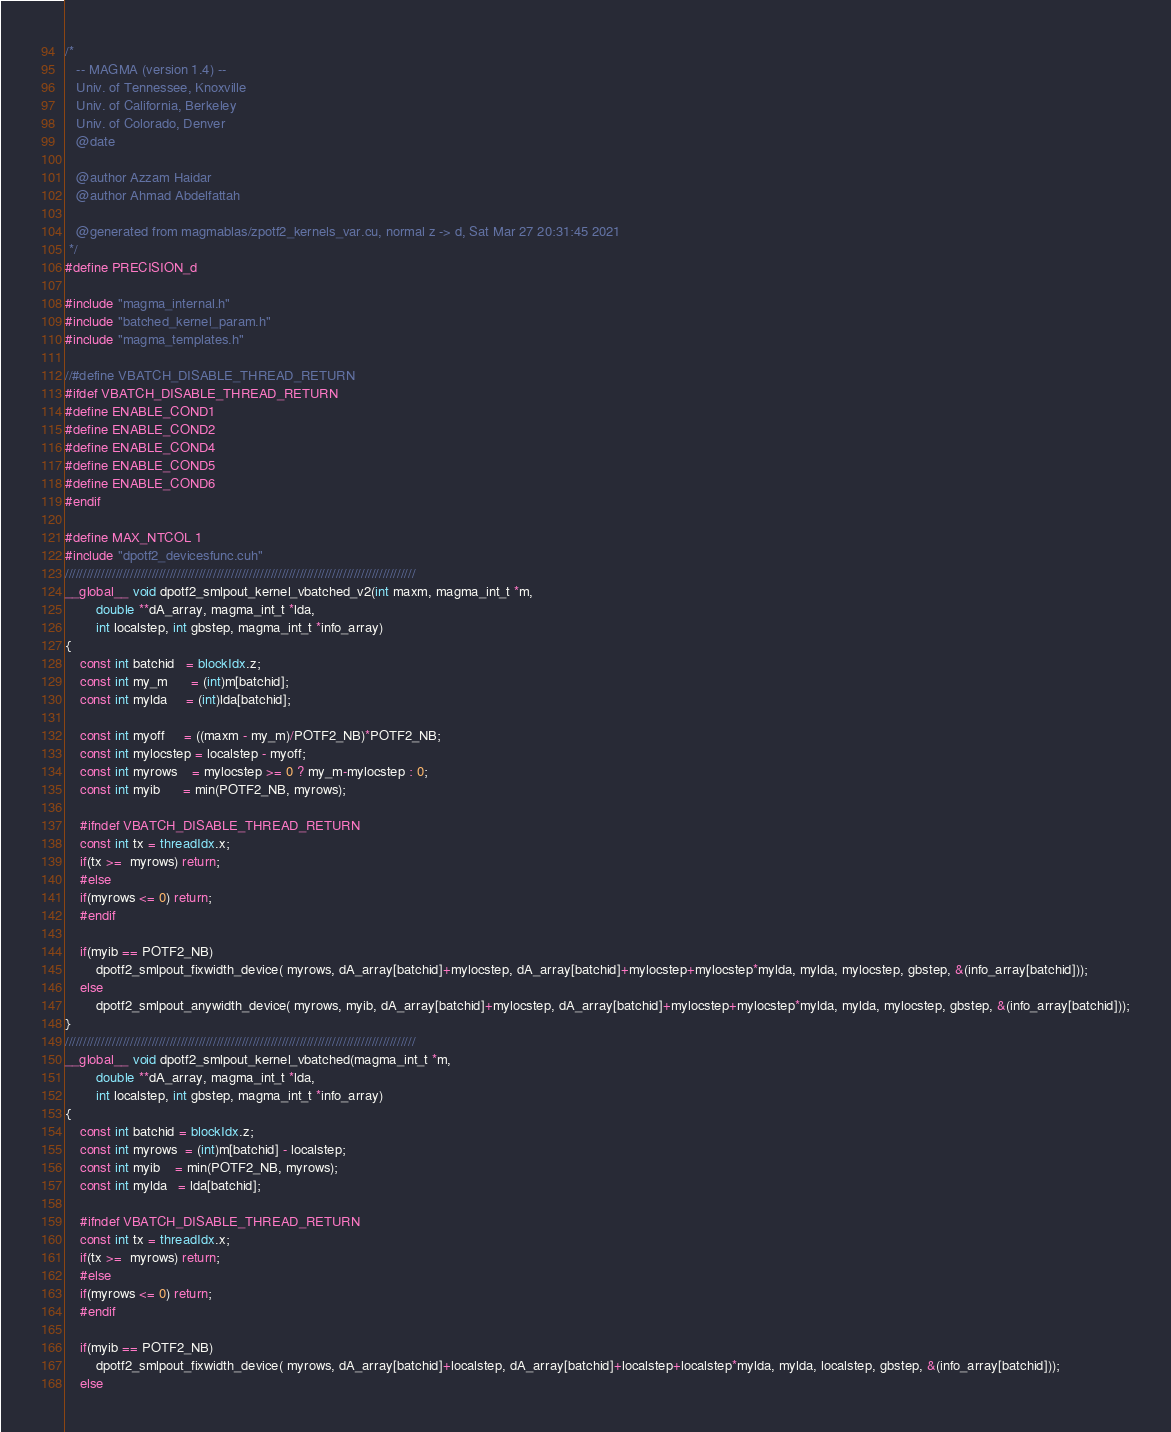<code> <loc_0><loc_0><loc_500><loc_500><_Cuda_>/*
   -- MAGMA (version 1.4) --
   Univ. of Tennessee, Knoxville
   Univ. of California, Berkeley
   Univ. of Colorado, Denver
   @date

   @author Azzam Haidar
   @author Ahmad Abdelfattah

   @generated from magmablas/zpotf2_kernels_var.cu, normal z -> d, Sat Mar 27 20:31:45 2021
 */
#define PRECISION_d

#include "magma_internal.h"
#include "batched_kernel_param.h"
#include "magma_templates.h"

//#define VBATCH_DISABLE_THREAD_RETURN
#ifdef VBATCH_DISABLE_THREAD_RETURN
#define ENABLE_COND1
#define ENABLE_COND2
#define ENABLE_COND4
#define ENABLE_COND5
#define ENABLE_COND6
#endif

#define MAX_NTCOL 1
#include "dpotf2_devicesfunc.cuh"
/////////////////////////////////////////////////////////////////////////////////////////////////
__global__ void dpotf2_smlpout_kernel_vbatched_v2(int maxm, magma_int_t *m,
        double **dA_array, magma_int_t *lda,
        int localstep, int gbstep, magma_int_t *info_array)
{
    const int batchid   = blockIdx.z;
    const int my_m      = (int)m[batchid];
    const int mylda     = (int)lda[batchid];

    const int myoff     = ((maxm - my_m)/POTF2_NB)*POTF2_NB;
    const int mylocstep = localstep - myoff;
    const int myrows    = mylocstep >= 0 ? my_m-mylocstep : 0;
    const int myib      = min(POTF2_NB, myrows);

    #ifndef VBATCH_DISABLE_THREAD_RETURN
    const int tx = threadIdx.x;
    if(tx >=  myrows) return;
    #else
    if(myrows <= 0) return;
    #endif

    if(myib == POTF2_NB)
        dpotf2_smlpout_fixwidth_device( myrows, dA_array[batchid]+mylocstep, dA_array[batchid]+mylocstep+mylocstep*mylda, mylda, mylocstep, gbstep, &(info_array[batchid]));
    else
        dpotf2_smlpout_anywidth_device( myrows, myib, dA_array[batchid]+mylocstep, dA_array[batchid]+mylocstep+mylocstep*mylda, mylda, mylocstep, gbstep, &(info_array[batchid]));
}
/////////////////////////////////////////////////////////////////////////////////////////////////
__global__ void dpotf2_smlpout_kernel_vbatched(magma_int_t *m,
        double **dA_array, magma_int_t *lda,
        int localstep, int gbstep, magma_int_t *info_array)
{
    const int batchid = blockIdx.z;
    const int myrows  = (int)m[batchid] - localstep;
    const int myib    = min(POTF2_NB, myrows);
    const int mylda   = lda[batchid];

    #ifndef VBATCH_DISABLE_THREAD_RETURN
    const int tx = threadIdx.x;
    if(tx >=  myrows) return;
    #else
    if(myrows <= 0) return;
    #endif

    if(myib == POTF2_NB)
        dpotf2_smlpout_fixwidth_device( myrows, dA_array[batchid]+localstep, dA_array[batchid]+localstep+localstep*mylda, mylda, localstep, gbstep, &(info_array[batchid]));
    else</code> 